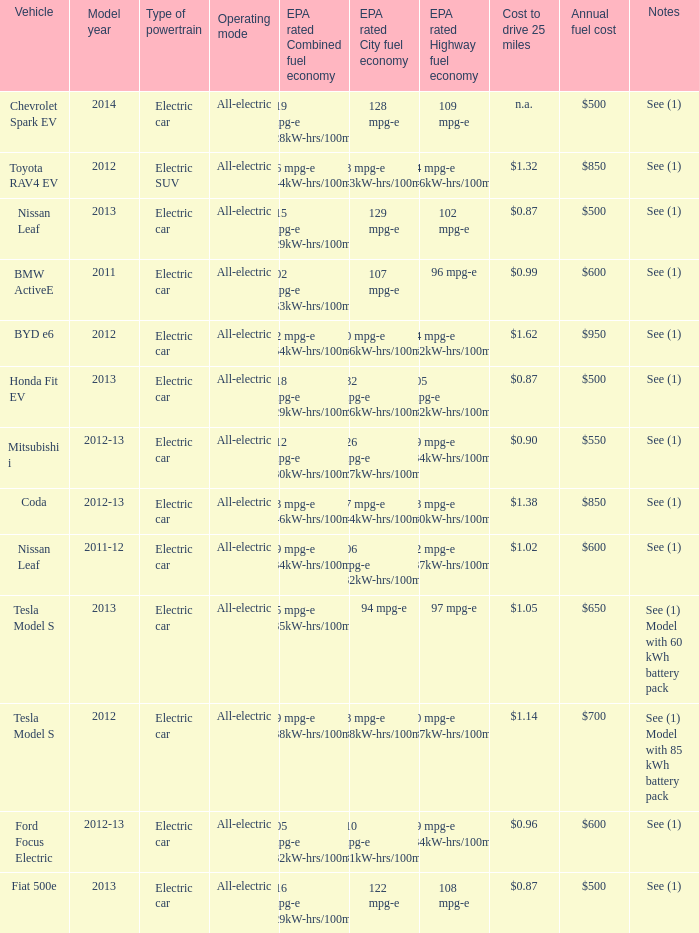What is the epa highway fuel economy for an electric suv? 74 mpg-e (46kW-hrs/100mi). 